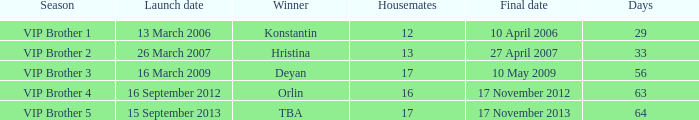What final date had 16 housemates? 17 November 2012. 